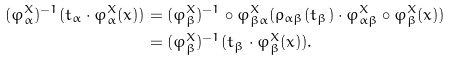<formula> <loc_0><loc_0><loc_500><loc_500>( \varphi ^ { X } _ { \alpha } ) ^ { - 1 } ( t _ { \alpha } \cdot \varphi ^ { X } _ { \alpha } ( x ) ) & = ( \varphi ^ { X } _ { \beta } ) ^ { - 1 } \circ \varphi ^ { X } _ { \beta \alpha } ( \rho _ { \alpha \beta } ( t _ { \beta } ) \cdot \varphi ^ { X } _ { \alpha \beta } \circ \varphi ^ { X } _ { \beta } ( x ) ) \\ & = ( \varphi ^ { X } _ { \beta } ) ^ { - 1 } ( t _ { \beta } \cdot \varphi ^ { X } _ { \beta } ( x ) ) .</formula> 